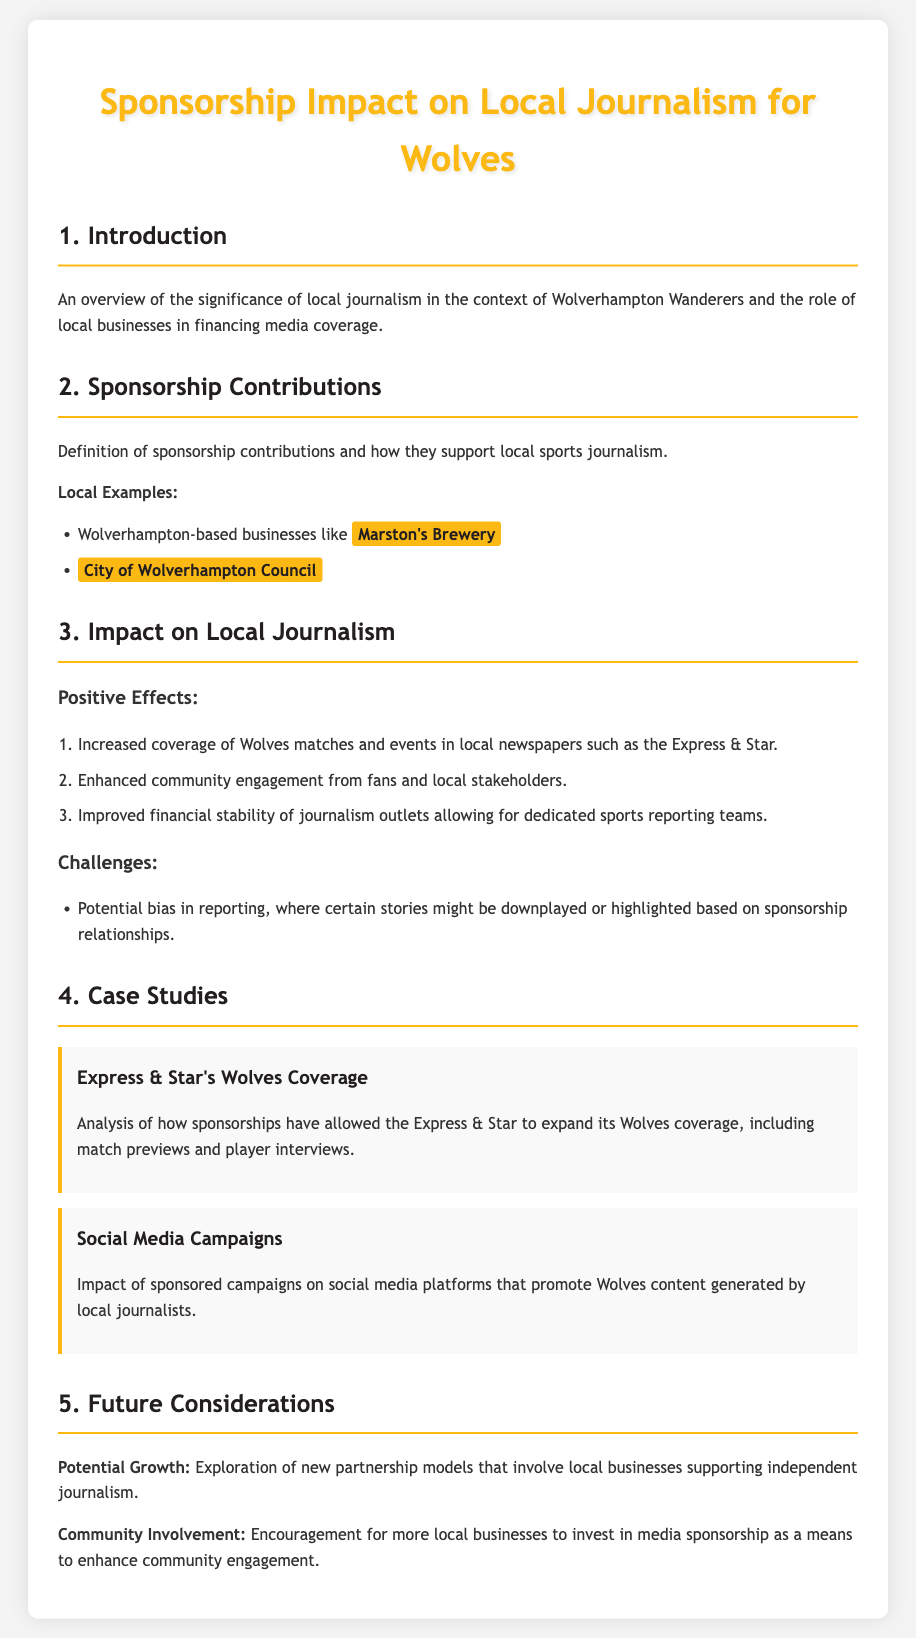What are sponsorship contributions? Sponsorship contributions are financial contributions from local businesses that support local sports journalism.
Answer: Financial contributions Which local business is mentioned as a sponsor? Marston's Brewery is highlighted as a local example of sponsorship.
Answer: Marston's Brewery What is one positive effect of sponsorship on local journalism? One positive effect is increased coverage of Wolves matches in local newspapers.
Answer: Increased coverage What challenge does sponsorship present in reporting? A challenge is potential bias in reporting based on sponsorship relationships.
Answer: Potential bias Which local journalism outlet expanded its Wolves coverage? The Express & Star has expanded its Wolves coverage due to sponsorships.
Answer: Express & Star What is a potential future consideration mentioned in the document? The document mentions exploring new partnership models for local business support of journalism.
Answer: New partnership models What community involvement is encouraged? The document encourages more local businesses to invest in media sponsorship.
Answer: Invest in media sponsorship How many positive effects of sponsorship are listed? Three positive effects of sponsorship are enumerated in the document.
Answer: Three 